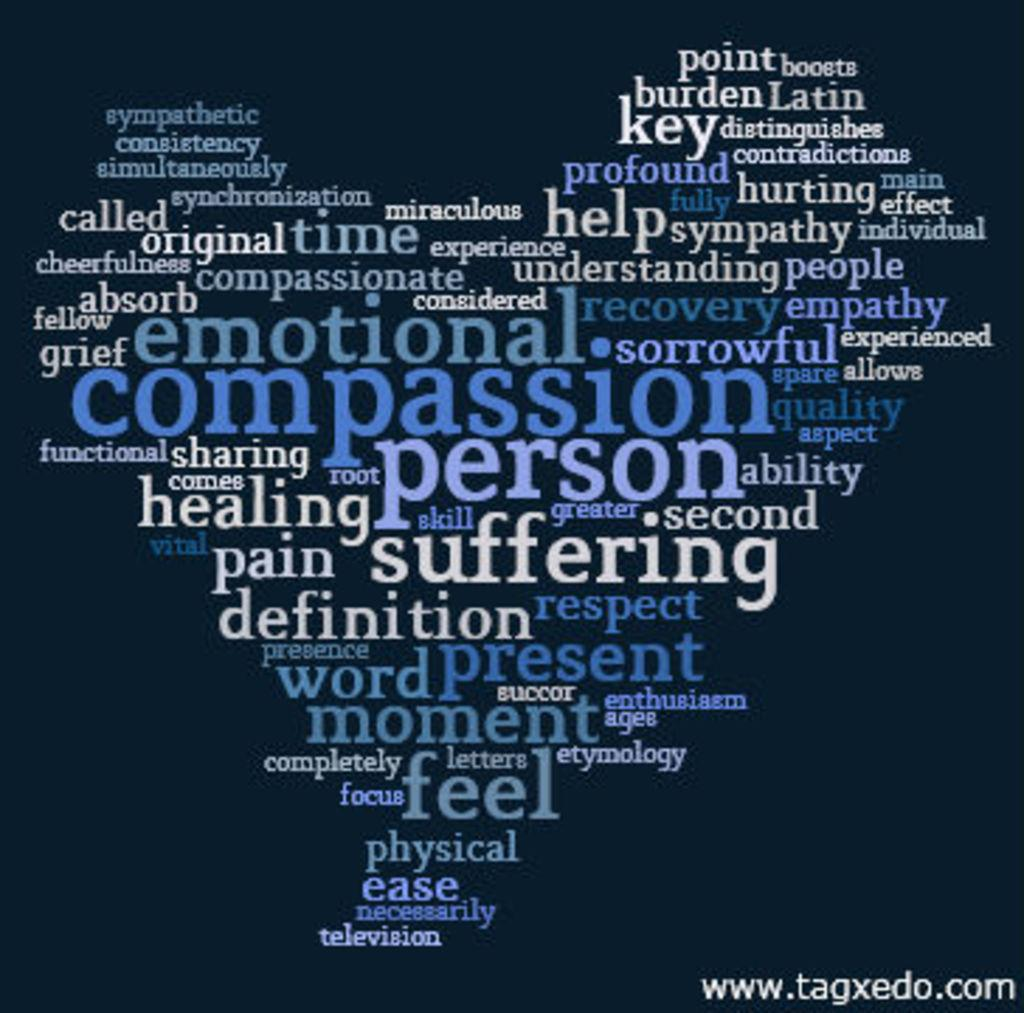<image>
Relay a brief, clear account of the picture shown. A poster of a word cloud with compassion as the biggest word. 